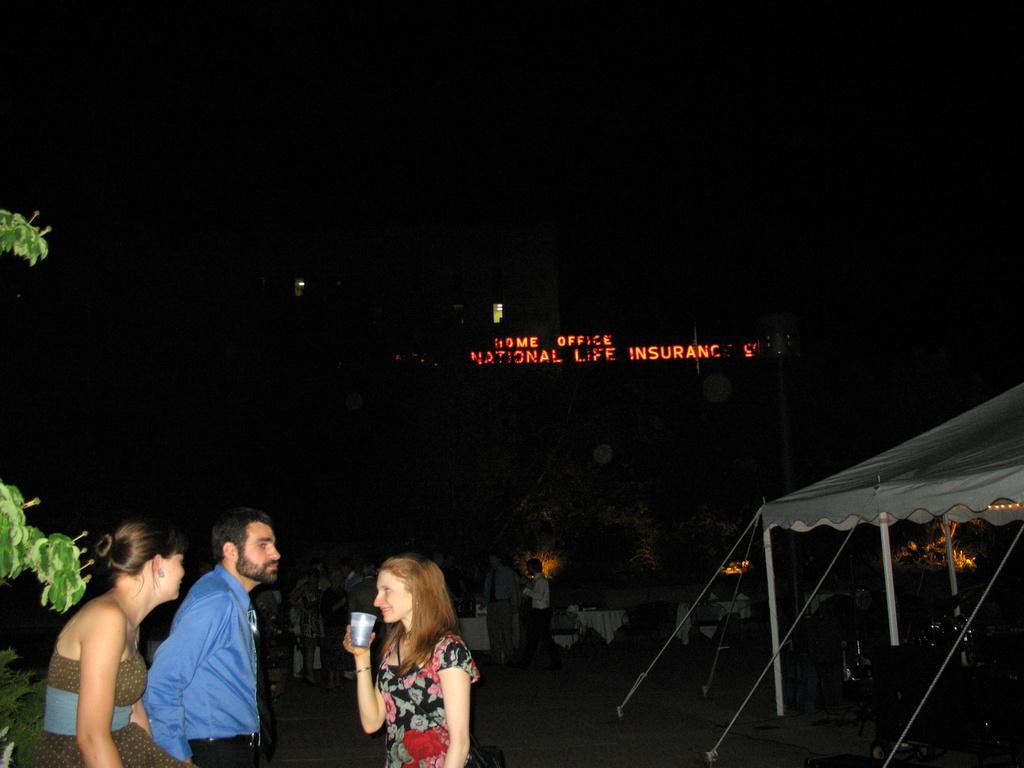Please provide a concise description of this image. In this image we can see there are a few people standing on the ground and there is the person holding a cup and there are leaves. And at the right side, we can see the tent, under the tent there are few objects. At the back there are tables with a cloth and we can see the building with text. 